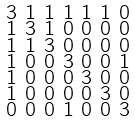<formula> <loc_0><loc_0><loc_500><loc_500>\begin{smallmatrix} 3 & 1 & 1 & 1 & 1 & 1 & 0 \\ 1 & 3 & 1 & 0 & 0 & 0 & 0 \\ 1 & 1 & 3 & 0 & 0 & 0 & 0 \\ 1 & 0 & 0 & 3 & 0 & 0 & 1 \\ 1 & 0 & 0 & 0 & 3 & 0 & 0 \\ 1 & 0 & 0 & 0 & 0 & 3 & 0 \\ 0 & 0 & 0 & 1 & 0 & 0 & 3 \end{smallmatrix}</formula> 